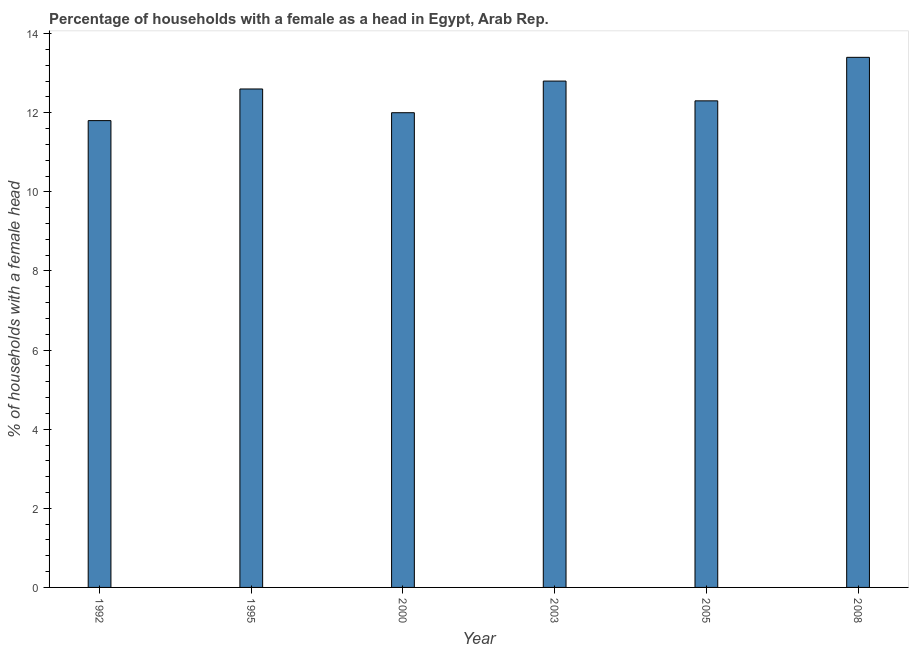Does the graph contain grids?
Provide a short and direct response. No. What is the title of the graph?
Your answer should be compact. Percentage of households with a female as a head in Egypt, Arab Rep. What is the label or title of the X-axis?
Ensure brevity in your answer.  Year. What is the label or title of the Y-axis?
Your answer should be compact. % of households with a female head. What is the number of female supervised households in 2008?
Offer a terse response. 13.4. Across all years, what is the minimum number of female supervised households?
Provide a succinct answer. 11.8. In which year was the number of female supervised households minimum?
Ensure brevity in your answer.  1992. What is the sum of the number of female supervised households?
Your response must be concise. 74.9. What is the average number of female supervised households per year?
Your answer should be compact. 12.48. What is the median number of female supervised households?
Offer a terse response. 12.45. In how many years, is the number of female supervised households greater than 11.6 %?
Your answer should be very brief. 6. What is the ratio of the number of female supervised households in 1995 to that in 2000?
Give a very brief answer. 1.05. Is the difference between the number of female supervised households in 2000 and 2003 greater than the difference between any two years?
Offer a very short reply. No. What is the difference between the highest and the second highest number of female supervised households?
Make the answer very short. 0.6. Is the sum of the number of female supervised households in 2000 and 2003 greater than the maximum number of female supervised households across all years?
Offer a terse response. Yes. What is the difference between the highest and the lowest number of female supervised households?
Provide a succinct answer. 1.6. In how many years, is the number of female supervised households greater than the average number of female supervised households taken over all years?
Your answer should be compact. 3. How many bars are there?
Offer a very short reply. 6. Are all the bars in the graph horizontal?
Make the answer very short. No. How many years are there in the graph?
Your answer should be very brief. 6. What is the % of households with a female head in 1992?
Give a very brief answer. 11.8. What is the % of households with a female head in 1995?
Your response must be concise. 12.6. What is the % of households with a female head of 2003?
Provide a short and direct response. 12.8. What is the difference between the % of households with a female head in 1992 and 1995?
Your response must be concise. -0.8. What is the difference between the % of households with a female head in 1992 and 2005?
Provide a short and direct response. -0.5. What is the difference between the % of households with a female head in 1992 and 2008?
Give a very brief answer. -1.6. What is the difference between the % of households with a female head in 1995 and 2005?
Provide a succinct answer. 0.3. What is the difference between the % of households with a female head in 2000 and 2005?
Your answer should be compact. -0.3. What is the difference between the % of households with a female head in 2003 and 2005?
Keep it short and to the point. 0.5. What is the difference between the % of households with a female head in 2003 and 2008?
Your response must be concise. -0.6. What is the ratio of the % of households with a female head in 1992 to that in 1995?
Provide a succinct answer. 0.94. What is the ratio of the % of households with a female head in 1992 to that in 2000?
Keep it short and to the point. 0.98. What is the ratio of the % of households with a female head in 1992 to that in 2003?
Offer a terse response. 0.92. What is the ratio of the % of households with a female head in 1992 to that in 2005?
Your answer should be very brief. 0.96. What is the ratio of the % of households with a female head in 1992 to that in 2008?
Provide a short and direct response. 0.88. What is the ratio of the % of households with a female head in 1995 to that in 2005?
Provide a succinct answer. 1.02. What is the ratio of the % of households with a female head in 1995 to that in 2008?
Give a very brief answer. 0.94. What is the ratio of the % of households with a female head in 2000 to that in 2003?
Provide a short and direct response. 0.94. What is the ratio of the % of households with a female head in 2000 to that in 2008?
Your response must be concise. 0.9. What is the ratio of the % of households with a female head in 2003 to that in 2005?
Offer a very short reply. 1.04. What is the ratio of the % of households with a female head in 2003 to that in 2008?
Provide a succinct answer. 0.95. What is the ratio of the % of households with a female head in 2005 to that in 2008?
Make the answer very short. 0.92. 